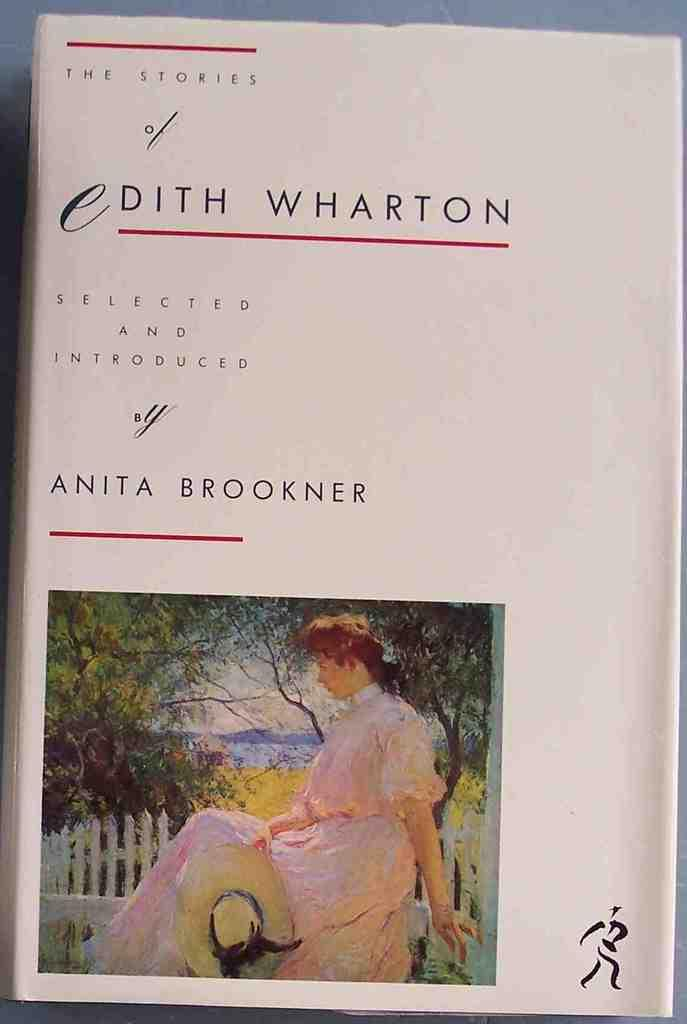<image>
Create a compact narrative representing the image presented. a book by Edith Wharton that has a white cover 